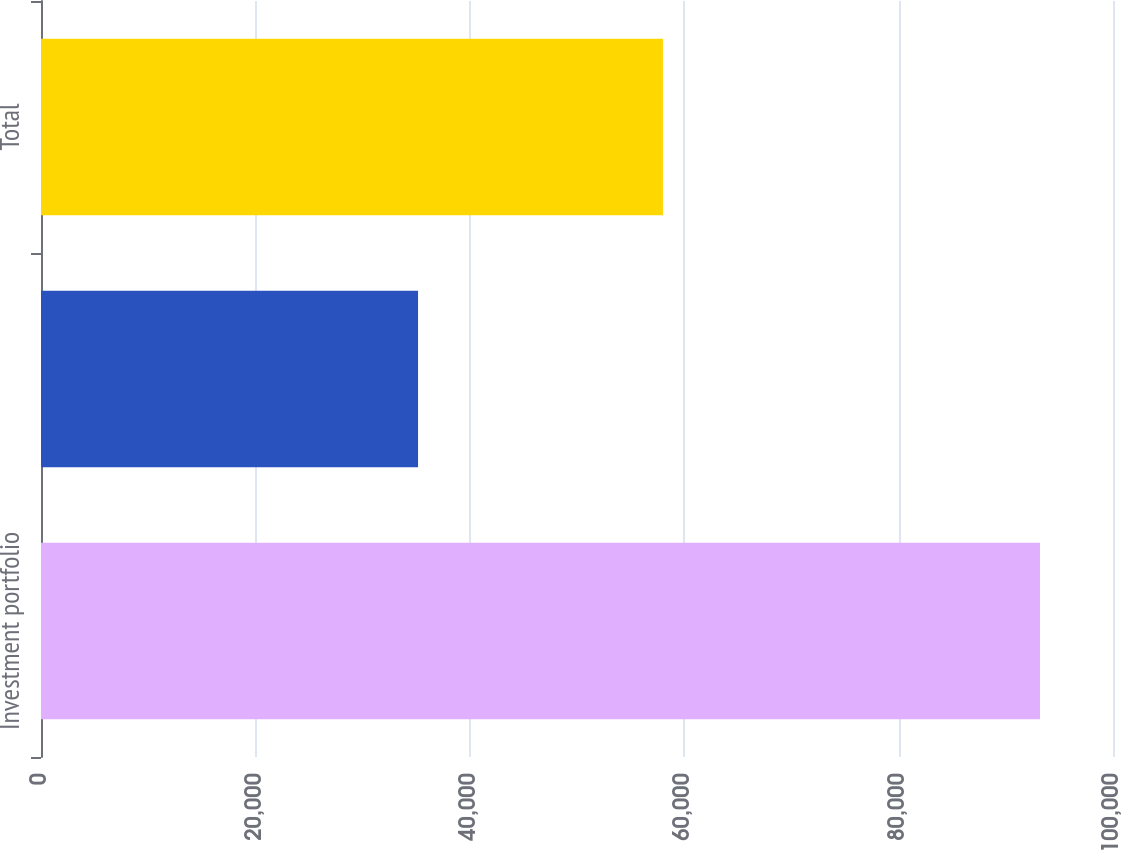Convert chart. <chart><loc_0><loc_0><loc_500><loc_500><bar_chart><fcel>Investment portfolio<fcel>Debt<fcel>Total<nl><fcel>93191<fcel>35173<fcel>58018<nl></chart> 